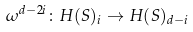<formula> <loc_0><loc_0><loc_500><loc_500>\omega ^ { d - 2 i } \colon H ( S ) _ { i } \rightarrow H ( S ) _ { d - i }</formula> 